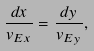<formula> <loc_0><loc_0><loc_500><loc_500>\frac { d x } { v _ { E x } } = \frac { d y } { v _ { E y } } ,</formula> 